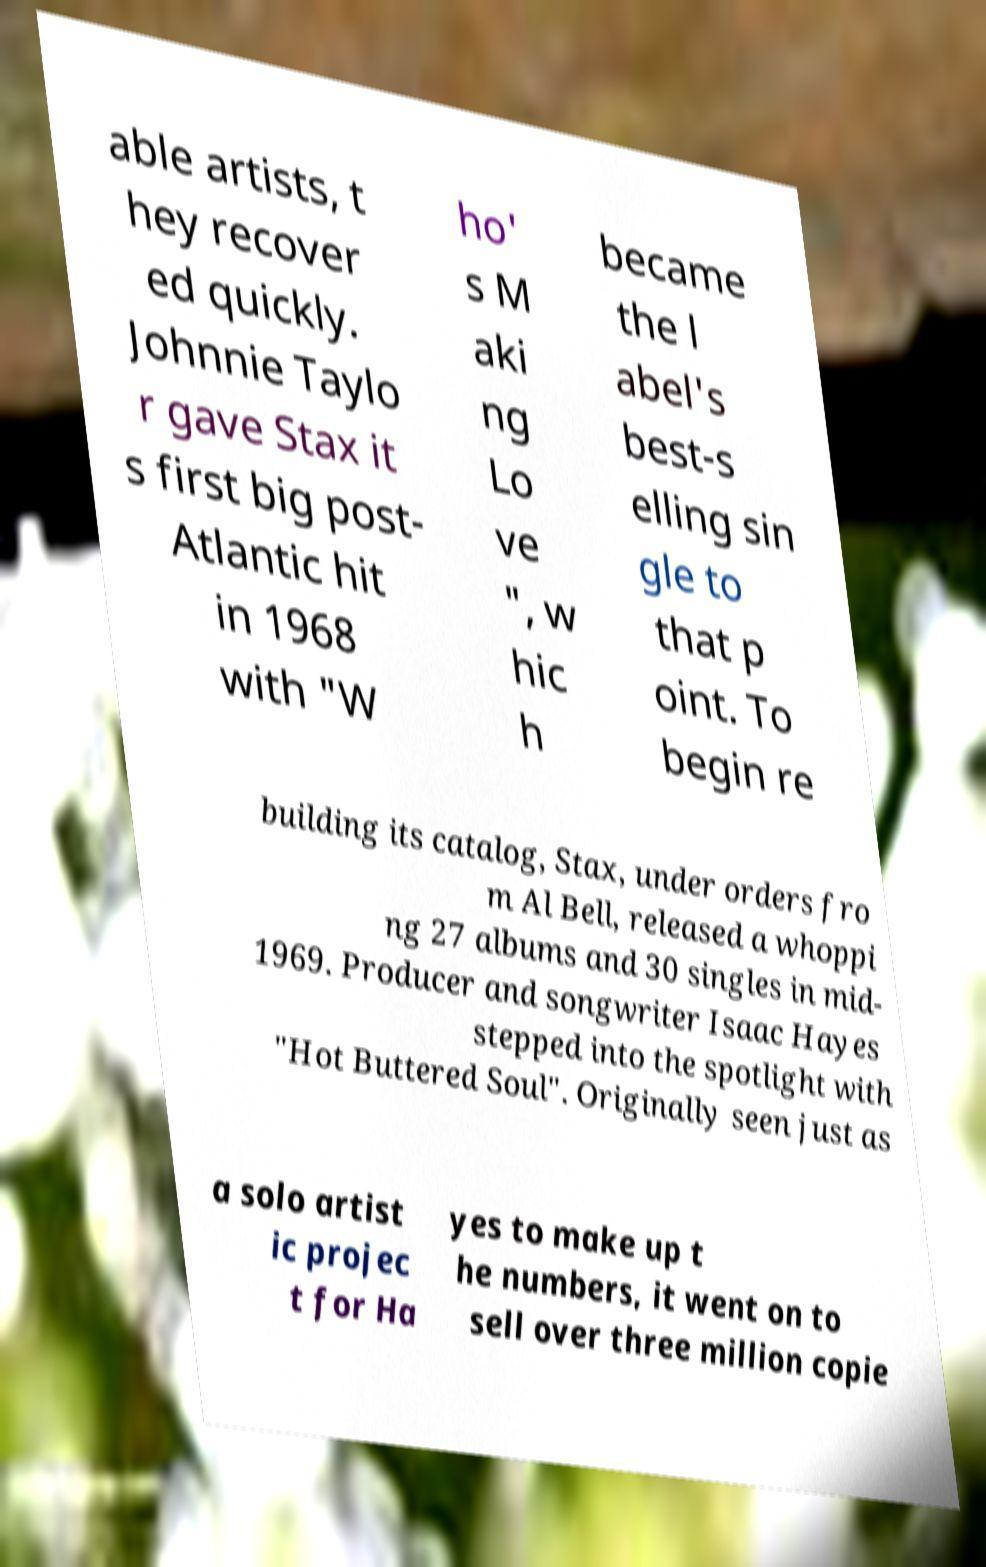What messages or text are displayed in this image? I need them in a readable, typed format. able artists, t hey recover ed quickly. Johnnie Taylo r gave Stax it s first big post- Atlantic hit in 1968 with "W ho' s M aki ng Lo ve ", w hic h became the l abel's best-s elling sin gle to that p oint. To begin re building its catalog, Stax, under orders fro m Al Bell, released a whoppi ng 27 albums and 30 singles in mid- 1969. Producer and songwriter Isaac Hayes stepped into the spotlight with "Hot Buttered Soul". Originally seen just as a solo artist ic projec t for Ha yes to make up t he numbers, it went on to sell over three million copie 